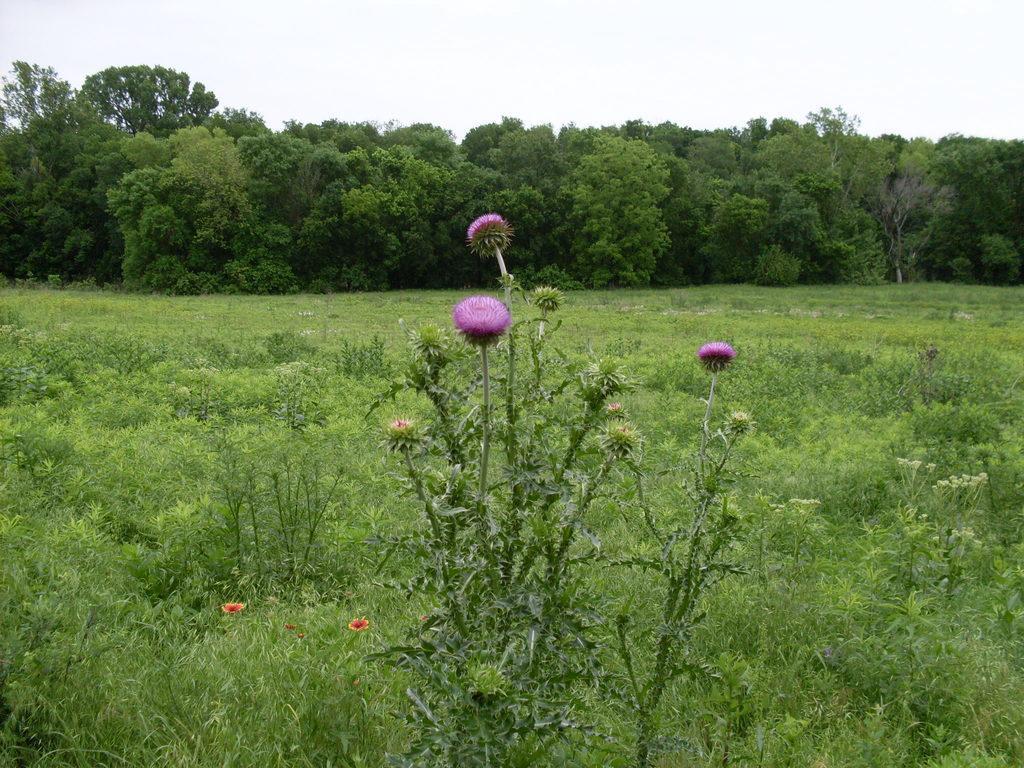Please provide a concise description of this image. Here we can see plants, flowers, and trees. This is grass. In the background there is sky. 